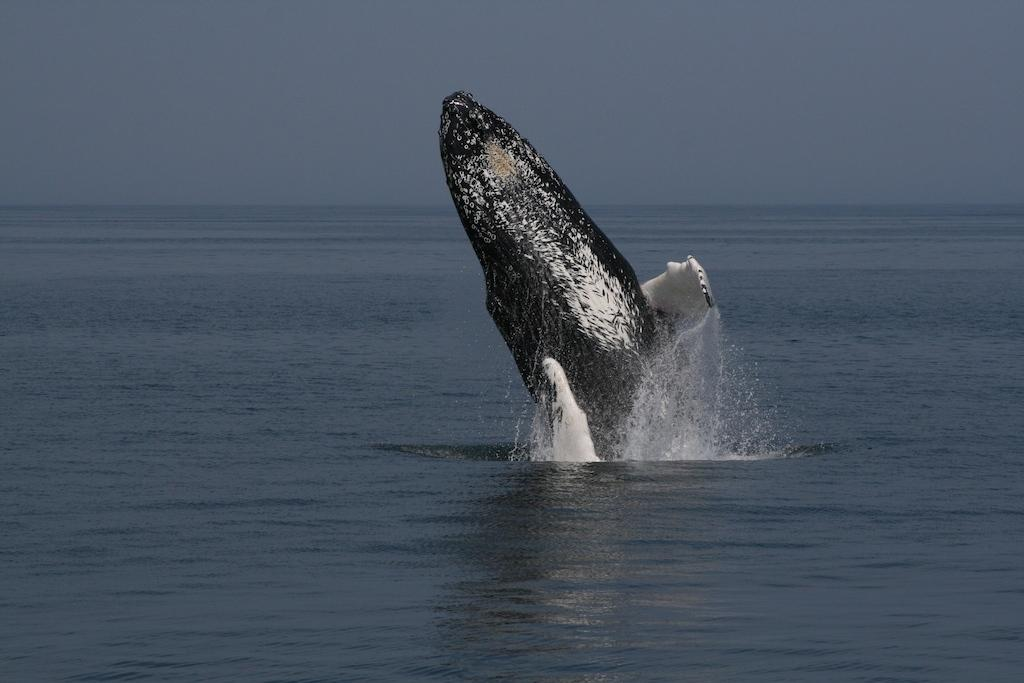What is in the water in the image? There is a shark in the water. What can be seen in the background of the image? The sky is visible in the background of the image. What type of soup is being served by the authority figure in the image? There is no authority figure or soup present in the image; it features a shark in the water and a visible sky in the background. 